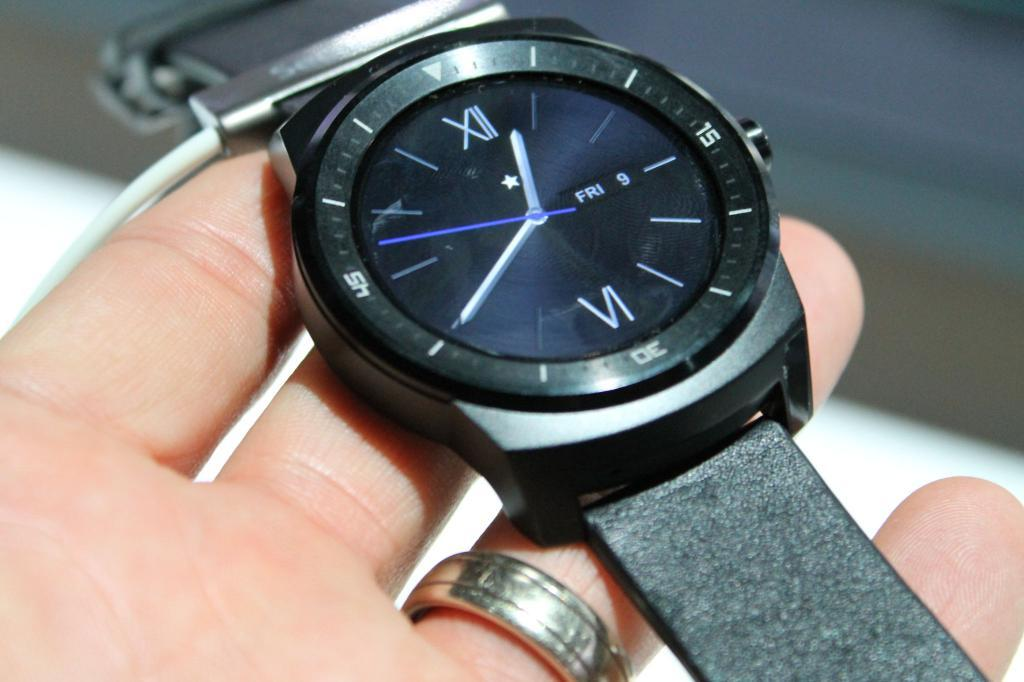<image>
Give a short and clear explanation of the subsequent image. A person is holding a watch whose date is set for Friday the 9th at 12:40. 